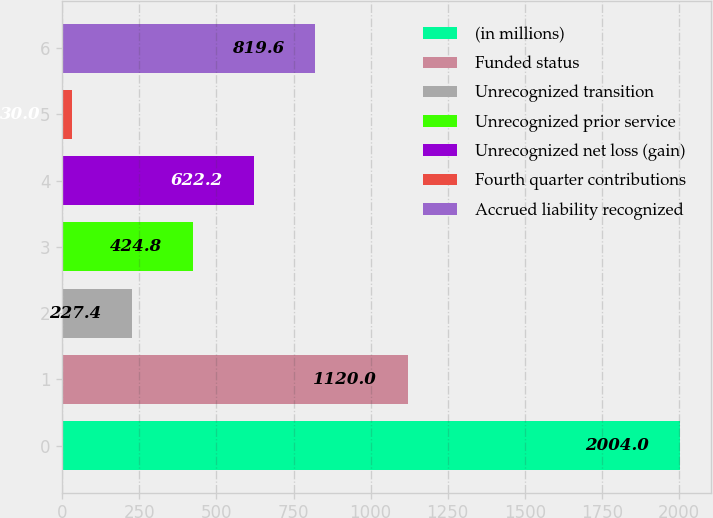<chart> <loc_0><loc_0><loc_500><loc_500><bar_chart><fcel>(in millions)<fcel>Funded status<fcel>Unrecognized transition<fcel>Unrecognized prior service<fcel>Unrecognized net loss (gain)<fcel>Fourth quarter contributions<fcel>Accrued liability recognized<nl><fcel>2004<fcel>1120<fcel>227.4<fcel>424.8<fcel>622.2<fcel>30<fcel>819.6<nl></chart> 